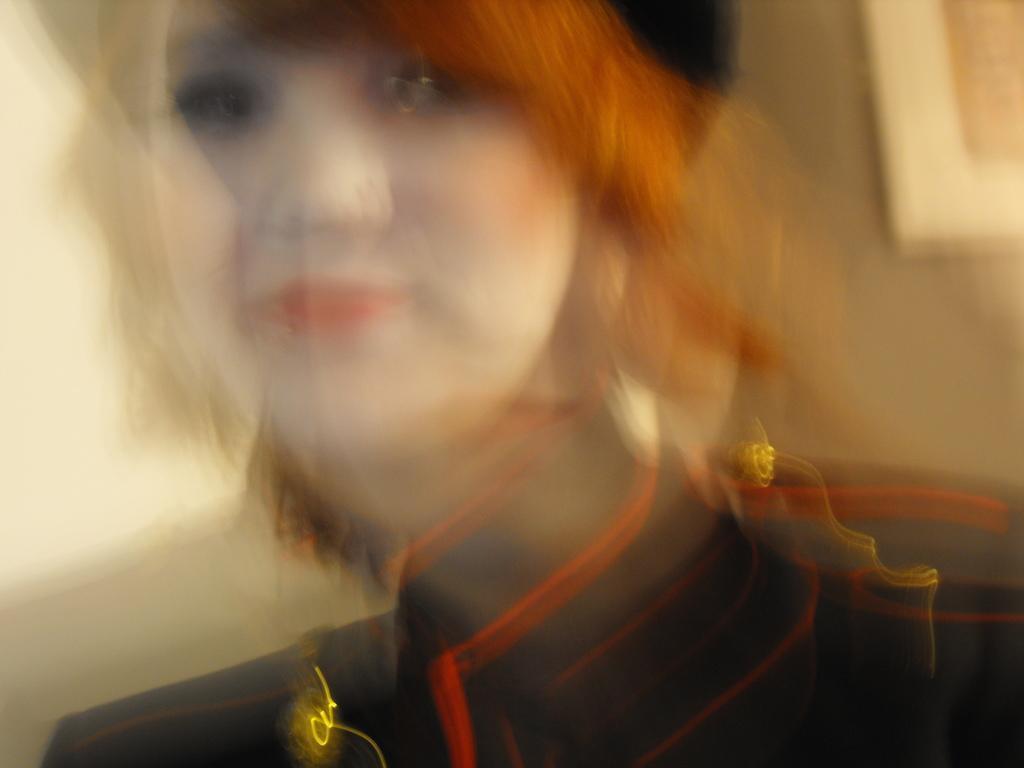Please provide a concise description of this image. The picture is blurred. In this picture there is a woman. 